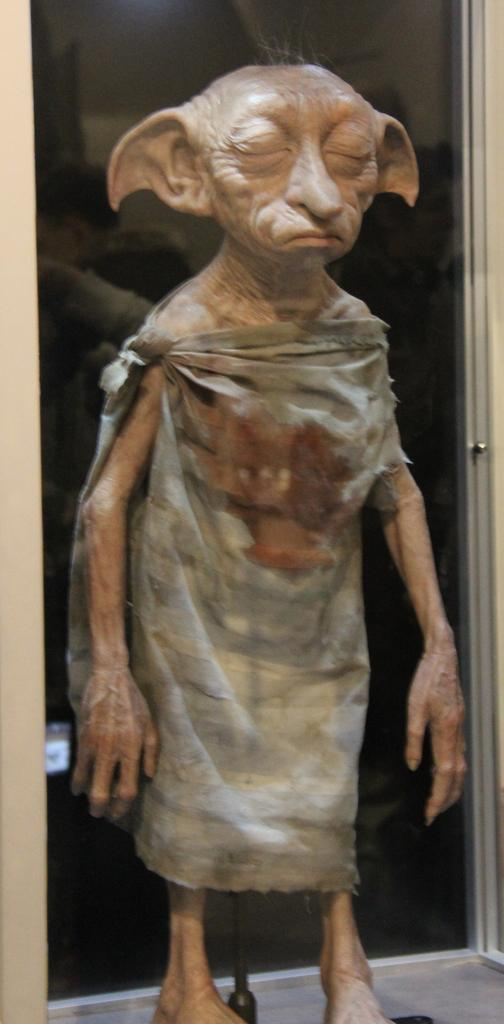What is the main subject of the image? The main subject of the image is a Warner Bros logo. Where is the logo located in the image? The Warner Bros logo is in the center of the image. What type of bean is being used to hold the pin in the image? There is no bean or pin present in the image; it only features the Warner Bros logo. 